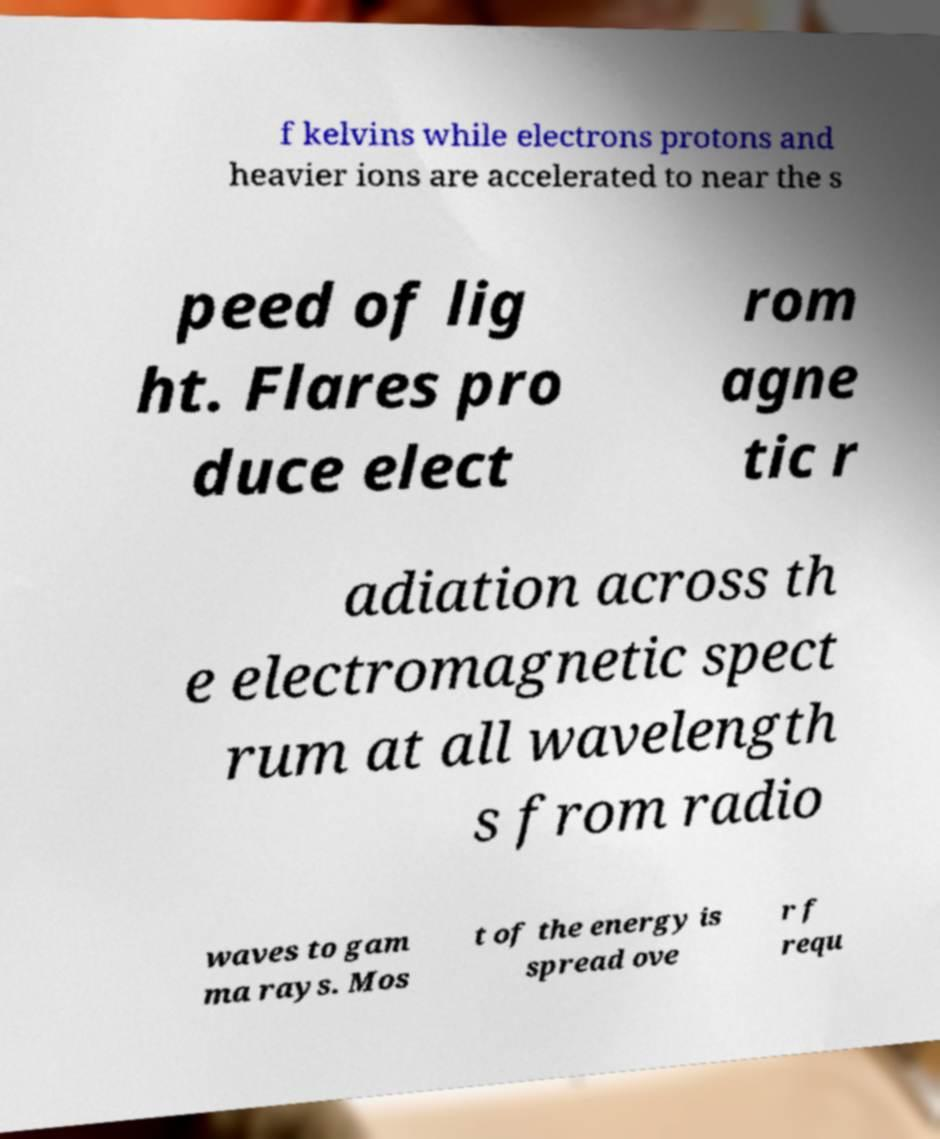For documentation purposes, I need the text within this image transcribed. Could you provide that? f kelvins while electrons protons and heavier ions are accelerated to near the s peed of lig ht. Flares pro duce elect rom agne tic r adiation across th e electromagnetic spect rum at all wavelength s from radio waves to gam ma rays. Mos t of the energy is spread ove r f requ 